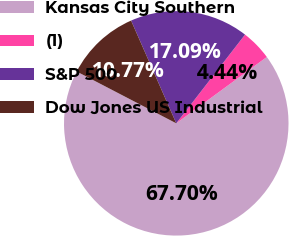<chart> <loc_0><loc_0><loc_500><loc_500><pie_chart><fcel>Kansas City Southern<fcel>(1)<fcel>S&P 500<fcel>Dow Jones US Industrial<nl><fcel>67.7%<fcel>4.44%<fcel>17.09%<fcel>10.77%<nl></chart> 